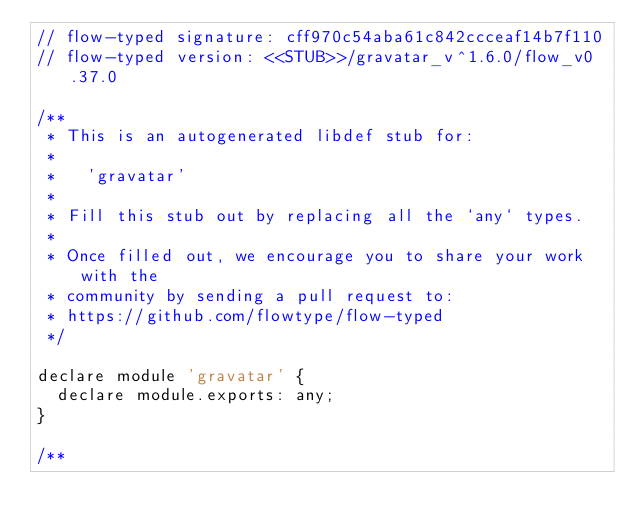Convert code to text. <code><loc_0><loc_0><loc_500><loc_500><_JavaScript_>// flow-typed signature: cff970c54aba61c842ccceaf14b7f110
// flow-typed version: <<STUB>>/gravatar_v^1.6.0/flow_v0.37.0

/**
 * This is an autogenerated libdef stub for:
 *
 *   'gravatar'
 *
 * Fill this stub out by replacing all the `any` types.
 *
 * Once filled out, we encourage you to share your work with the
 * community by sending a pull request to:
 * https://github.com/flowtype/flow-typed
 */

declare module 'gravatar' {
  declare module.exports: any;
}

/**</code> 